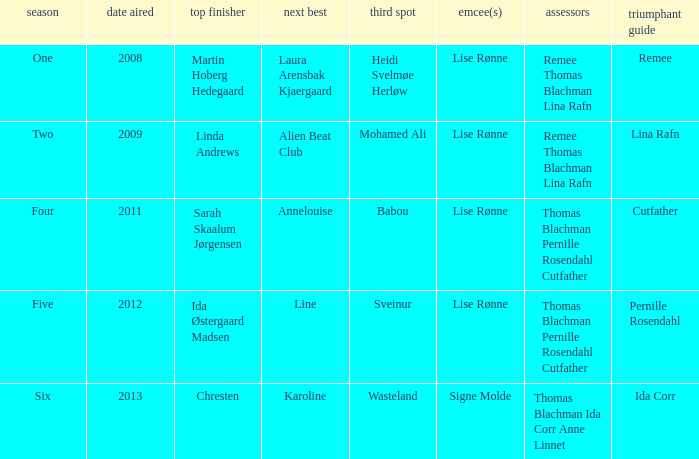Write the full table. {'header': ['season', 'date aired', 'top finisher', 'next best', 'third spot', 'emcee(s)', 'assessors', 'triumphant guide'], 'rows': [['One', '2008', 'Martin Hoberg Hedegaard', 'Laura Arensbak Kjaergaard', 'Heidi Svelmøe Herløw', 'Lise Rønne', 'Remee Thomas Blachman Lina Rafn', 'Remee'], ['Two', '2009', 'Linda Andrews', 'Alien Beat Club', 'Mohamed Ali', 'Lise Rønne', 'Remee Thomas Blachman Lina Rafn', 'Lina Rafn'], ['Four', '2011', 'Sarah Skaalum Jørgensen', 'Annelouise', 'Babou', 'Lise Rønne', 'Thomas Blachman Pernille Rosendahl Cutfather', 'Cutfather'], ['Five', '2012', 'Ida Østergaard Madsen', 'Line', 'Sveinur', 'Lise Rønne', 'Thomas Blachman Pernille Rosendahl Cutfather', 'Pernille Rosendahl'], ['Six', '2013', 'Chresten', 'Karoline', 'Wasteland', 'Signe Molde', 'Thomas Blachman Ida Corr Anne Linnet', 'Ida Corr']]} Who was the runner-up in season five? Line. 